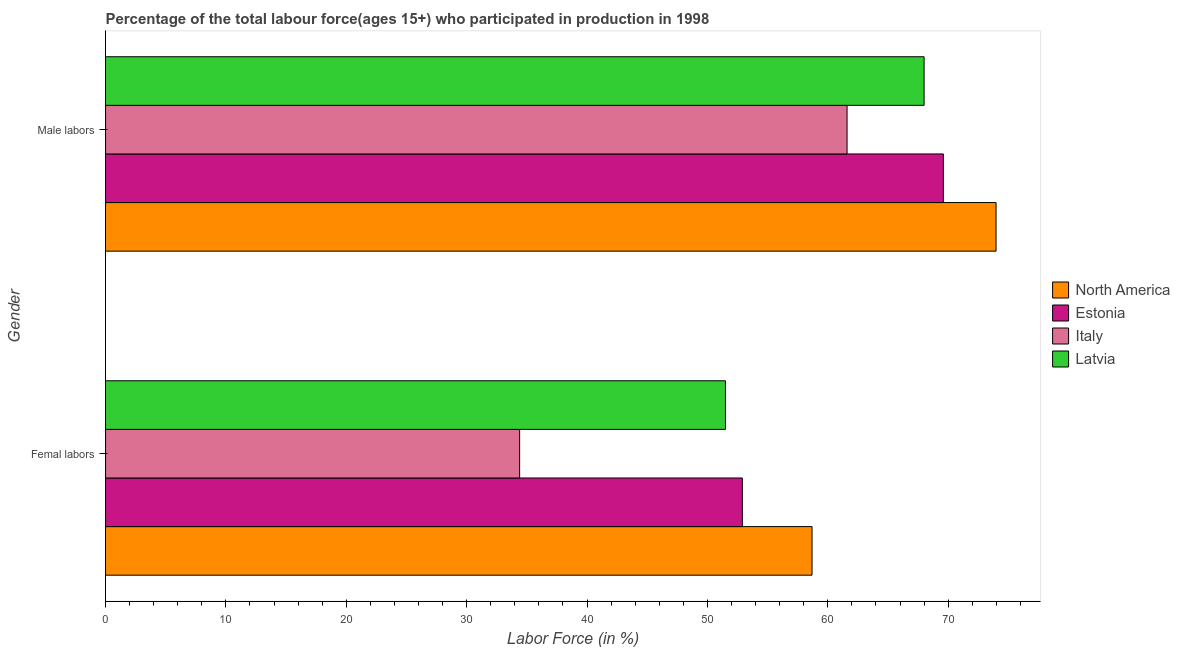How many different coloured bars are there?
Provide a succinct answer. 4. How many groups of bars are there?
Provide a short and direct response. 2. Are the number of bars on each tick of the Y-axis equal?
Your answer should be compact. Yes. What is the label of the 1st group of bars from the top?
Provide a short and direct response. Male labors. What is the percentage of male labour force in North America?
Your answer should be very brief. 73.98. Across all countries, what is the maximum percentage of female labor force?
Your answer should be compact. 58.69. Across all countries, what is the minimum percentage of male labour force?
Your answer should be compact. 61.6. In which country was the percentage of female labor force maximum?
Make the answer very short. North America. What is the total percentage of female labor force in the graph?
Offer a very short reply. 197.49. What is the difference between the percentage of male labour force in Italy and that in Latvia?
Your answer should be compact. -6.4. What is the difference between the percentage of male labour force in Italy and the percentage of female labor force in Estonia?
Offer a terse response. 8.7. What is the average percentage of male labour force per country?
Keep it short and to the point. 68.29. What is the difference between the percentage of female labor force and percentage of male labour force in Italy?
Offer a very short reply. -27.2. In how many countries, is the percentage of female labor force greater than 8 %?
Your response must be concise. 4. What is the ratio of the percentage of male labour force in Latvia to that in Italy?
Your answer should be compact. 1.1. What does the 4th bar from the bottom in Male labors represents?
Your answer should be very brief. Latvia. How many bars are there?
Provide a short and direct response. 8. How many countries are there in the graph?
Offer a very short reply. 4. Are the values on the major ticks of X-axis written in scientific E-notation?
Give a very brief answer. No. Where does the legend appear in the graph?
Keep it short and to the point. Center right. How many legend labels are there?
Ensure brevity in your answer.  4. What is the title of the graph?
Keep it short and to the point. Percentage of the total labour force(ages 15+) who participated in production in 1998. Does "Guinea" appear as one of the legend labels in the graph?
Offer a very short reply. No. What is the label or title of the X-axis?
Give a very brief answer. Labor Force (in %). What is the label or title of the Y-axis?
Offer a terse response. Gender. What is the Labor Force (in %) of North America in Femal labors?
Your answer should be very brief. 58.69. What is the Labor Force (in %) of Estonia in Femal labors?
Your response must be concise. 52.9. What is the Labor Force (in %) of Italy in Femal labors?
Offer a terse response. 34.4. What is the Labor Force (in %) in Latvia in Femal labors?
Ensure brevity in your answer.  51.5. What is the Labor Force (in %) in North America in Male labors?
Offer a terse response. 73.98. What is the Labor Force (in %) of Estonia in Male labors?
Offer a very short reply. 69.6. What is the Labor Force (in %) in Italy in Male labors?
Make the answer very short. 61.6. Across all Gender, what is the maximum Labor Force (in %) of North America?
Your response must be concise. 73.98. Across all Gender, what is the maximum Labor Force (in %) in Estonia?
Ensure brevity in your answer.  69.6. Across all Gender, what is the maximum Labor Force (in %) in Italy?
Provide a short and direct response. 61.6. Across all Gender, what is the maximum Labor Force (in %) of Latvia?
Ensure brevity in your answer.  68. Across all Gender, what is the minimum Labor Force (in %) in North America?
Make the answer very short. 58.69. Across all Gender, what is the minimum Labor Force (in %) in Estonia?
Make the answer very short. 52.9. Across all Gender, what is the minimum Labor Force (in %) of Italy?
Your response must be concise. 34.4. Across all Gender, what is the minimum Labor Force (in %) of Latvia?
Your response must be concise. 51.5. What is the total Labor Force (in %) in North America in the graph?
Keep it short and to the point. 132.67. What is the total Labor Force (in %) in Estonia in the graph?
Your answer should be very brief. 122.5. What is the total Labor Force (in %) of Italy in the graph?
Your response must be concise. 96. What is the total Labor Force (in %) of Latvia in the graph?
Offer a very short reply. 119.5. What is the difference between the Labor Force (in %) in North America in Femal labors and that in Male labors?
Provide a short and direct response. -15.29. What is the difference between the Labor Force (in %) of Estonia in Femal labors and that in Male labors?
Keep it short and to the point. -16.7. What is the difference between the Labor Force (in %) in Italy in Femal labors and that in Male labors?
Offer a very short reply. -27.2. What is the difference between the Labor Force (in %) in Latvia in Femal labors and that in Male labors?
Keep it short and to the point. -16.5. What is the difference between the Labor Force (in %) of North America in Femal labors and the Labor Force (in %) of Estonia in Male labors?
Your answer should be compact. -10.91. What is the difference between the Labor Force (in %) in North America in Femal labors and the Labor Force (in %) in Italy in Male labors?
Your answer should be very brief. -2.91. What is the difference between the Labor Force (in %) of North America in Femal labors and the Labor Force (in %) of Latvia in Male labors?
Provide a succinct answer. -9.31. What is the difference between the Labor Force (in %) of Estonia in Femal labors and the Labor Force (in %) of Italy in Male labors?
Keep it short and to the point. -8.7. What is the difference between the Labor Force (in %) of Estonia in Femal labors and the Labor Force (in %) of Latvia in Male labors?
Provide a short and direct response. -15.1. What is the difference between the Labor Force (in %) in Italy in Femal labors and the Labor Force (in %) in Latvia in Male labors?
Make the answer very short. -33.6. What is the average Labor Force (in %) in North America per Gender?
Your answer should be very brief. 66.33. What is the average Labor Force (in %) of Estonia per Gender?
Your response must be concise. 61.25. What is the average Labor Force (in %) of Italy per Gender?
Provide a short and direct response. 48. What is the average Labor Force (in %) of Latvia per Gender?
Give a very brief answer. 59.75. What is the difference between the Labor Force (in %) of North America and Labor Force (in %) of Estonia in Femal labors?
Provide a short and direct response. 5.79. What is the difference between the Labor Force (in %) of North America and Labor Force (in %) of Italy in Femal labors?
Make the answer very short. 24.29. What is the difference between the Labor Force (in %) of North America and Labor Force (in %) of Latvia in Femal labors?
Your answer should be compact. 7.19. What is the difference between the Labor Force (in %) in Estonia and Labor Force (in %) in Italy in Femal labors?
Your answer should be very brief. 18.5. What is the difference between the Labor Force (in %) of Italy and Labor Force (in %) of Latvia in Femal labors?
Your answer should be very brief. -17.1. What is the difference between the Labor Force (in %) in North America and Labor Force (in %) in Estonia in Male labors?
Provide a short and direct response. 4.38. What is the difference between the Labor Force (in %) in North America and Labor Force (in %) in Italy in Male labors?
Give a very brief answer. 12.38. What is the difference between the Labor Force (in %) of North America and Labor Force (in %) of Latvia in Male labors?
Your answer should be compact. 5.98. What is the difference between the Labor Force (in %) of Estonia and Labor Force (in %) of Italy in Male labors?
Give a very brief answer. 8. What is the difference between the Labor Force (in %) in Estonia and Labor Force (in %) in Latvia in Male labors?
Keep it short and to the point. 1.6. What is the ratio of the Labor Force (in %) of North America in Femal labors to that in Male labors?
Keep it short and to the point. 0.79. What is the ratio of the Labor Force (in %) of Estonia in Femal labors to that in Male labors?
Provide a short and direct response. 0.76. What is the ratio of the Labor Force (in %) of Italy in Femal labors to that in Male labors?
Give a very brief answer. 0.56. What is the ratio of the Labor Force (in %) of Latvia in Femal labors to that in Male labors?
Ensure brevity in your answer.  0.76. What is the difference between the highest and the second highest Labor Force (in %) of North America?
Your answer should be very brief. 15.29. What is the difference between the highest and the second highest Labor Force (in %) of Estonia?
Offer a very short reply. 16.7. What is the difference between the highest and the second highest Labor Force (in %) of Italy?
Make the answer very short. 27.2. What is the difference between the highest and the second highest Labor Force (in %) of Latvia?
Your answer should be compact. 16.5. What is the difference between the highest and the lowest Labor Force (in %) in North America?
Provide a short and direct response. 15.29. What is the difference between the highest and the lowest Labor Force (in %) in Italy?
Ensure brevity in your answer.  27.2. 